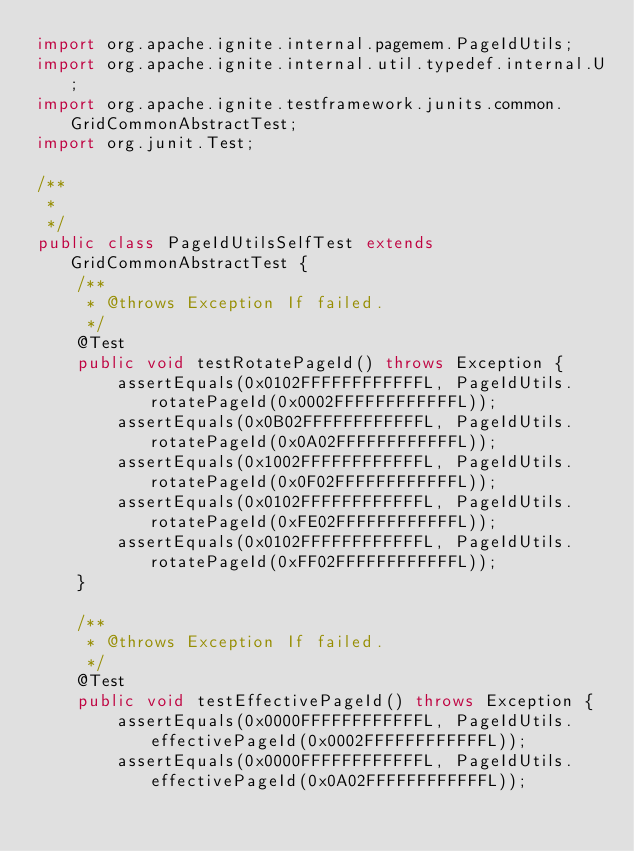Convert code to text. <code><loc_0><loc_0><loc_500><loc_500><_Java_>import org.apache.ignite.internal.pagemem.PageIdUtils;
import org.apache.ignite.internal.util.typedef.internal.U;
import org.apache.ignite.testframework.junits.common.GridCommonAbstractTest;
import org.junit.Test;

/**
 *
 */
public class PageIdUtilsSelfTest extends GridCommonAbstractTest {
    /**
     * @throws Exception If failed.
     */
    @Test
    public void testRotatePageId() throws Exception {
        assertEquals(0x0102FFFFFFFFFFFFL, PageIdUtils.rotatePageId(0x0002FFFFFFFFFFFFL));
        assertEquals(0x0B02FFFFFFFFFFFFL, PageIdUtils.rotatePageId(0x0A02FFFFFFFFFFFFL));
        assertEquals(0x1002FFFFFFFFFFFFL, PageIdUtils.rotatePageId(0x0F02FFFFFFFFFFFFL));
        assertEquals(0x0102FFFFFFFFFFFFL, PageIdUtils.rotatePageId(0xFE02FFFFFFFFFFFFL));
        assertEquals(0x0102FFFFFFFFFFFFL, PageIdUtils.rotatePageId(0xFF02FFFFFFFFFFFFL));
    }

    /**
     * @throws Exception If failed.
     */
    @Test
    public void testEffectivePageId() throws Exception {
        assertEquals(0x0000FFFFFFFFFFFFL, PageIdUtils.effectivePageId(0x0002FFFFFFFFFFFFL));
        assertEquals(0x0000FFFFFFFFFFFFL, PageIdUtils.effectivePageId(0x0A02FFFFFFFFFFFFL));</code> 